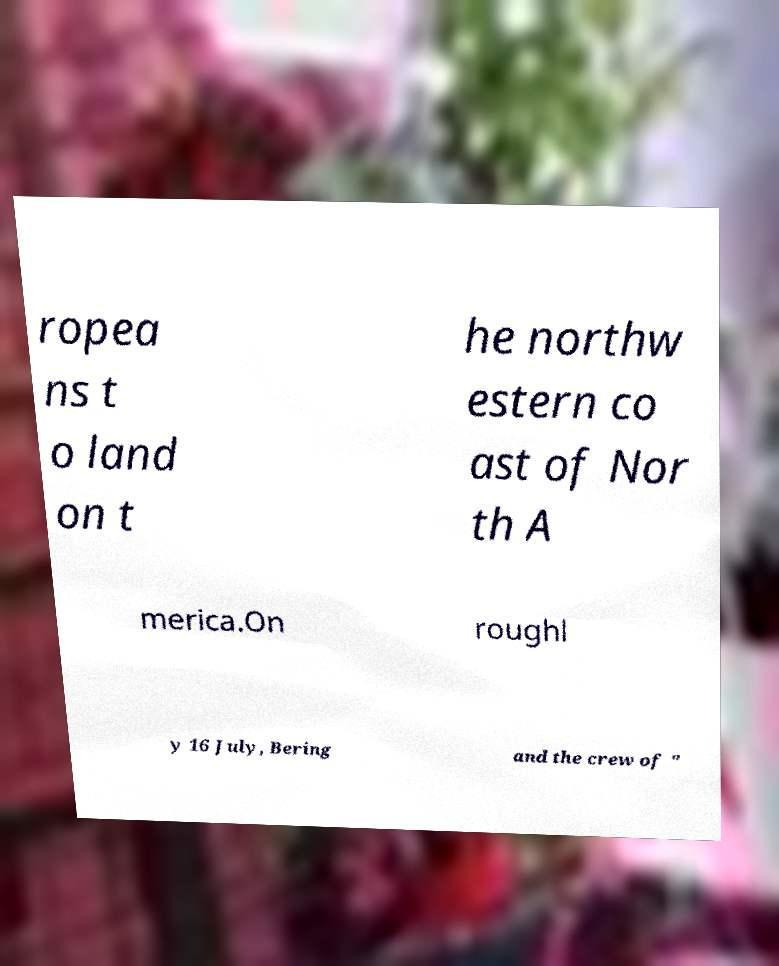Please identify and transcribe the text found in this image. ropea ns t o land on t he northw estern co ast of Nor th A merica.On roughl y 16 July, Bering and the crew of " 